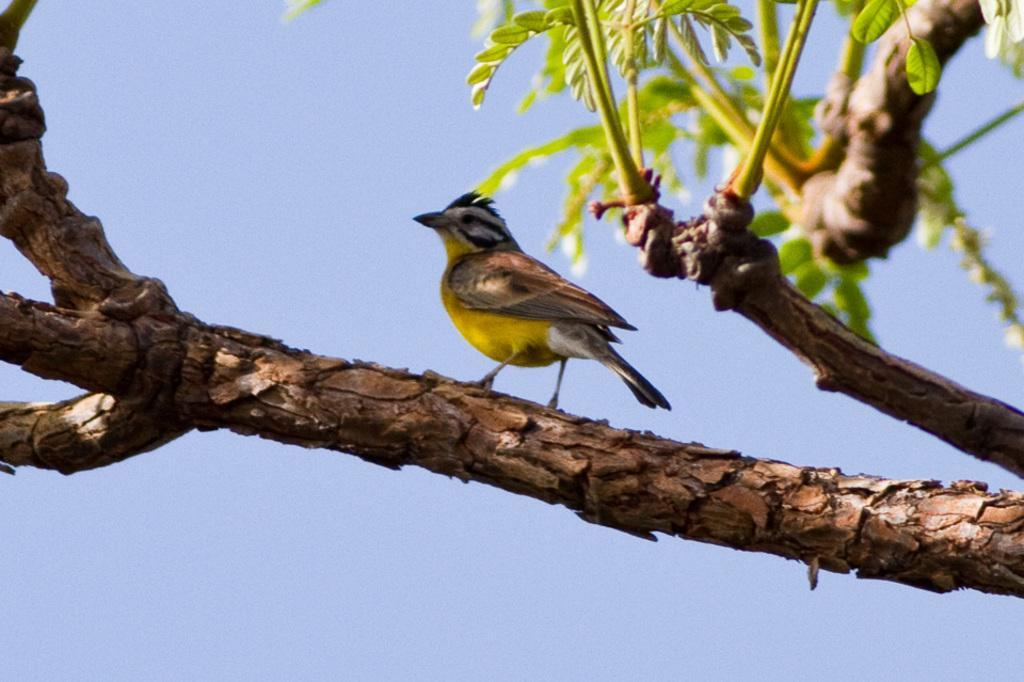Describe this image in one or two sentences. In this image I can see few branches of a tree and in the front I can see a yellow and brown colour bird. On the top right side of this image I can see green leaves and in the background I can see the sky. 